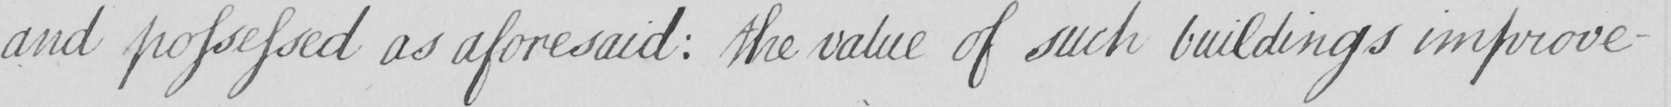Please provide the text content of this handwritten line. and possessed as aforesaid :  the value of such buildings improve- 